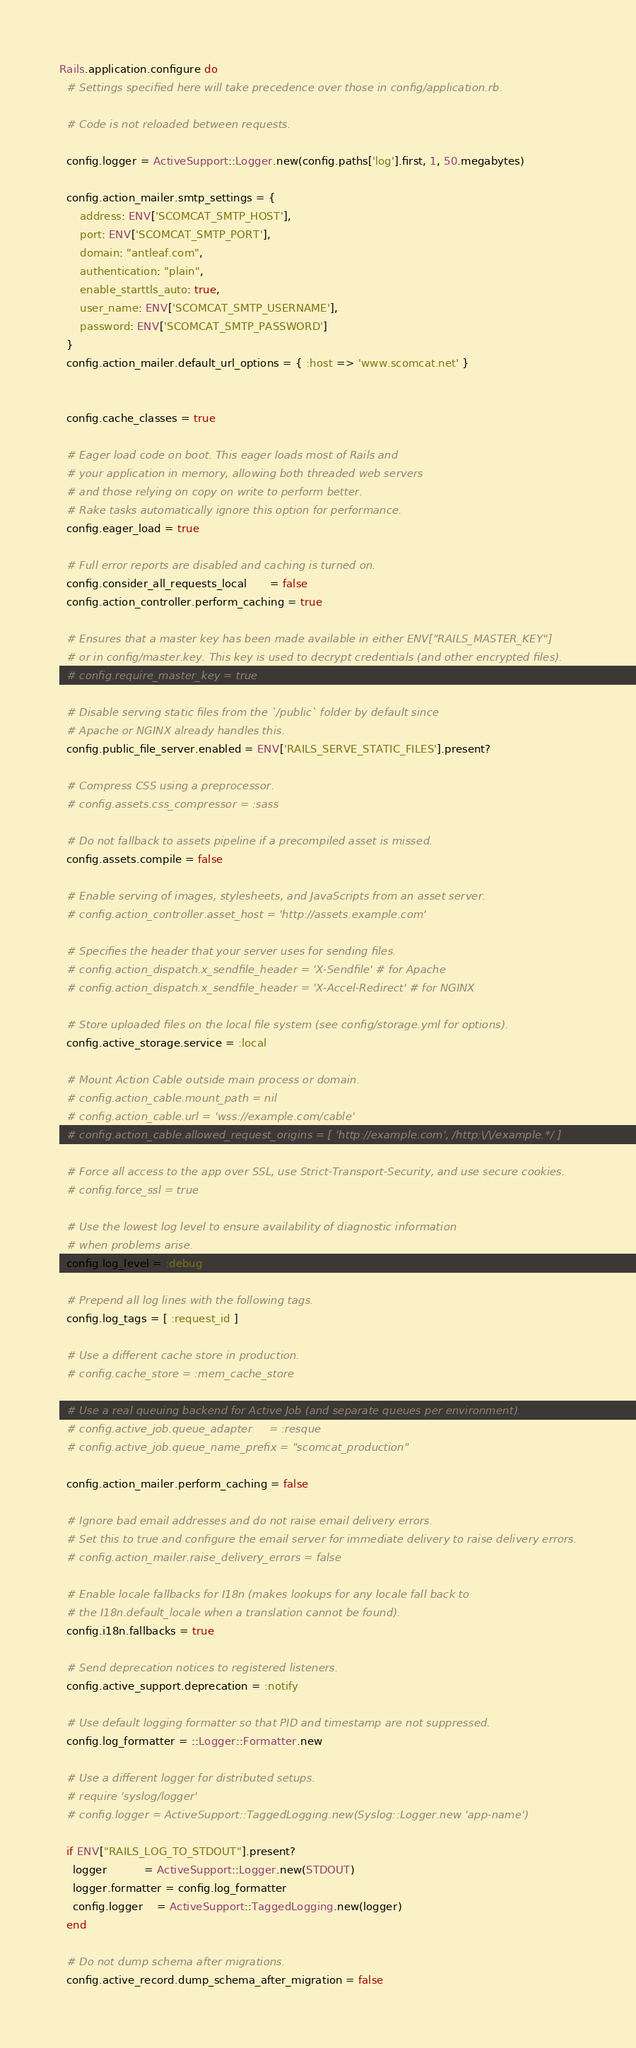Convert code to text. <code><loc_0><loc_0><loc_500><loc_500><_Ruby_>Rails.application.configure do
  # Settings specified here will take precedence over those in config/application.rb.

  # Code is not reloaded between requests.

  config.logger = ActiveSupport::Logger.new(config.paths['log'].first, 1, 50.megabytes)

  config.action_mailer.smtp_settings = {
      address: ENV['SCOMCAT_SMTP_HOST'],
      port: ENV['SCOMCAT_SMTP_PORT'],
      domain: "antleaf.com",
      authentication: "plain",
      enable_starttls_auto: true,
      user_name: ENV['SCOMCAT_SMTP_USERNAME'],
      password: ENV['SCOMCAT_SMTP_PASSWORD']
  }
  config.action_mailer.default_url_options = { :host => 'www.scomcat.net' }


  config.cache_classes = true

  # Eager load code on boot. This eager loads most of Rails and
  # your application in memory, allowing both threaded web servers
  # and those relying on copy on write to perform better.
  # Rake tasks automatically ignore this option for performance.
  config.eager_load = true

  # Full error reports are disabled and caching is turned on.
  config.consider_all_requests_local       = false
  config.action_controller.perform_caching = true

  # Ensures that a master key has been made available in either ENV["RAILS_MASTER_KEY"]
  # or in config/master.key. This key is used to decrypt credentials (and other encrypted files).
  # config.require_master_key = true

  # Disable serving static files from the `/public` folder by default since
  # Apache or NGINX already handles this.
  config.public_file_server.enabled = ENV['RAILS_SERVE_STATIC_FILES'].present?

  # Compress CSS using a preprocessor.
  # config.assets.css_compressor = :sass

  # Do not fallback to assets pipeline if a precompiled asset is missed.
  config.assets.compile = false

  # Enable serving of images, stylesheets, and JavaScripts from an asset server.
  # config.action_controller.asset_host = 'http://assets.example.com'

  # Specifies the header that your server uses for sending files.
  # config.action_dispatch.x_sendfile_header = 'X-Sendfile' # for Apache
  # config.action_dispatch.x_sendfile_header = 'X-Accel-Redirect' # for NGINX

  # Store uploaded files on the local file system (see config/storage.yml for options).
  config.active_storage.service = :local

  # Mount Action Cable outside main process or domain.
  # config.action_cable.mount_path = nil
  # config.action_cable.url = 'wss://example.com/cable'
  # config.action_cable.allowed_request_origins = [ 'http://example.com', /http:\/\/example.*/ ]

  # Force all access to the app over SSL, use Strict-Transport-Security, and use secure cookies.
  # config.force_ssl = true

  # Use the lowest log level to ensure availability of diagnostic information
  # when problems arise.
  config.log_level = :debug

  # Prepend all log lines with the following tags.
  config.log_tags = [ :request_id ]

  # Use a different cache store in production.
  # config.cache_store = :mem_cache_store

  # Use a real queuing backend for Active Job (and separate queues per environment).
  # config.active_job.queue_adapter     = :resque
  # config.active_job.queue_name_prefix = "scomcat_production"

  config.action_mailer.perform_caching = false

  # Ignore bad email addresses and do not raise email delivery errors.
  # Set this to true and configure the email server for immediate delivery to raise delivery errors.
  # config.action_mailer.raise_delivery_errors = false

  # Enable locale fallbacks for I18n (makes lookups for any locale fall back to
  # the I18n.default_locale when a translation cannot be found).
  config.i18n.fallbacks = true

  # Send deprecation notices to registered listeners.
  config.active_support.deprecation = :notify

  # Use default logging formatter so that PID and timestamp are not suppressed.
  config.log_formatter = ::Logger::Formatter.new

  # Use a different logger for distributed setups.
  # require 'syslog/logger'
  # config.logger = ActiveSupport::TaggedLogging.new(Syslog::Logger.new 'app-name')

  if ENV["RAILS_LOG_TO_STDOUT"].present?
    logger           = ActiveSupport::Logger.new(STDOUT)
    logger.formatter = config.log_formatter
    config.logger    = ActiveSupport::TaggedLogging.new(logger)
  end

  # Do not dump schema after migrations.
  config.active_record.dump_schema_after_migration = false
</code> 